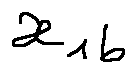<formula> <loc_0><loc_0><loc_500><loc_500>x _ { l b }</formula> 